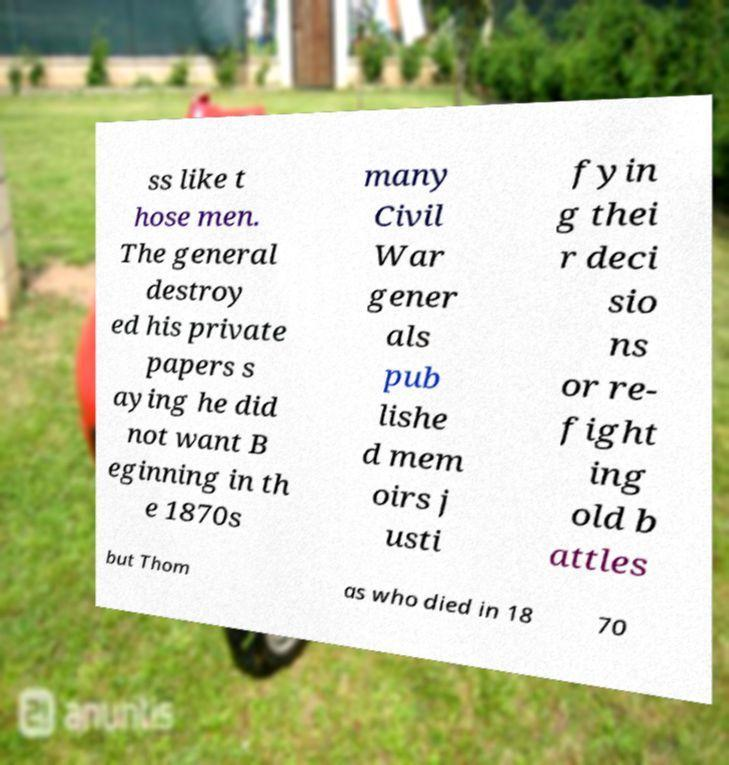There's text embedded in this image that I need extracted. Can you transcribe it verbatim? ss like t hose men. The general destroy ed his private papers s aying he did not want B eginning in th e 1870s many Civil War gener als pub lishe d mem oirs j usti fyin g thei r deci sio ns or re- fight ing old b attles but Thom as who died in 18 70 